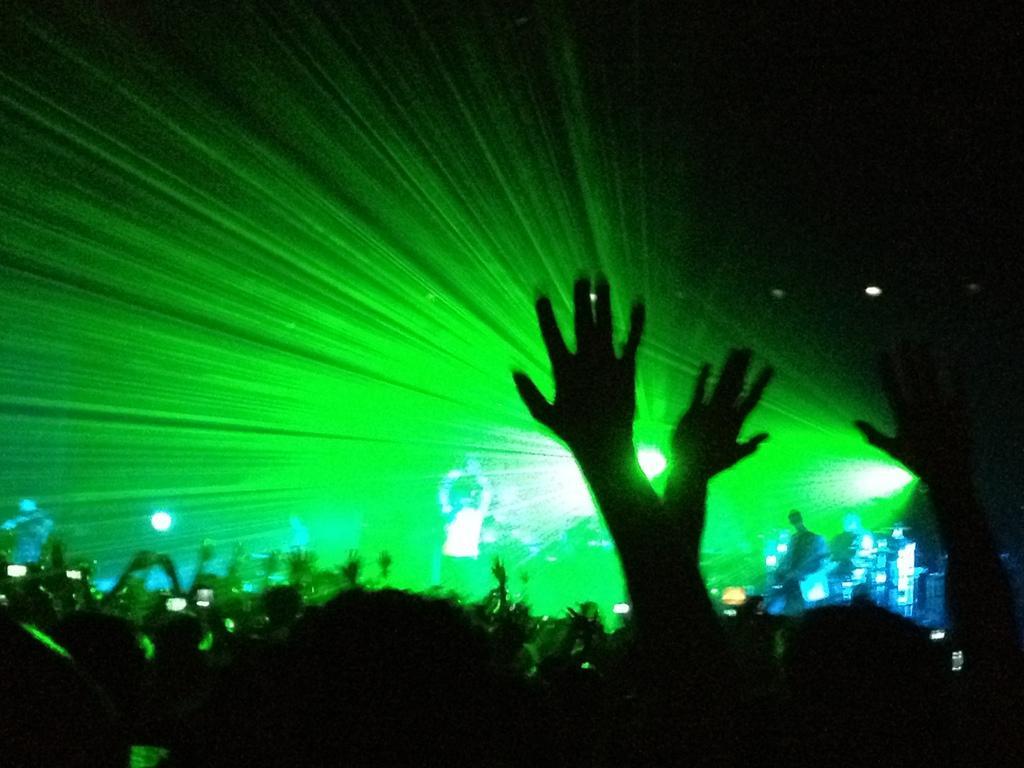Could you give a brief overview of what you see in this image? This picture is taken in the dark, where we can see these people are standing here and these people are standing on the stage. In the background, we can see the green color show lights. 